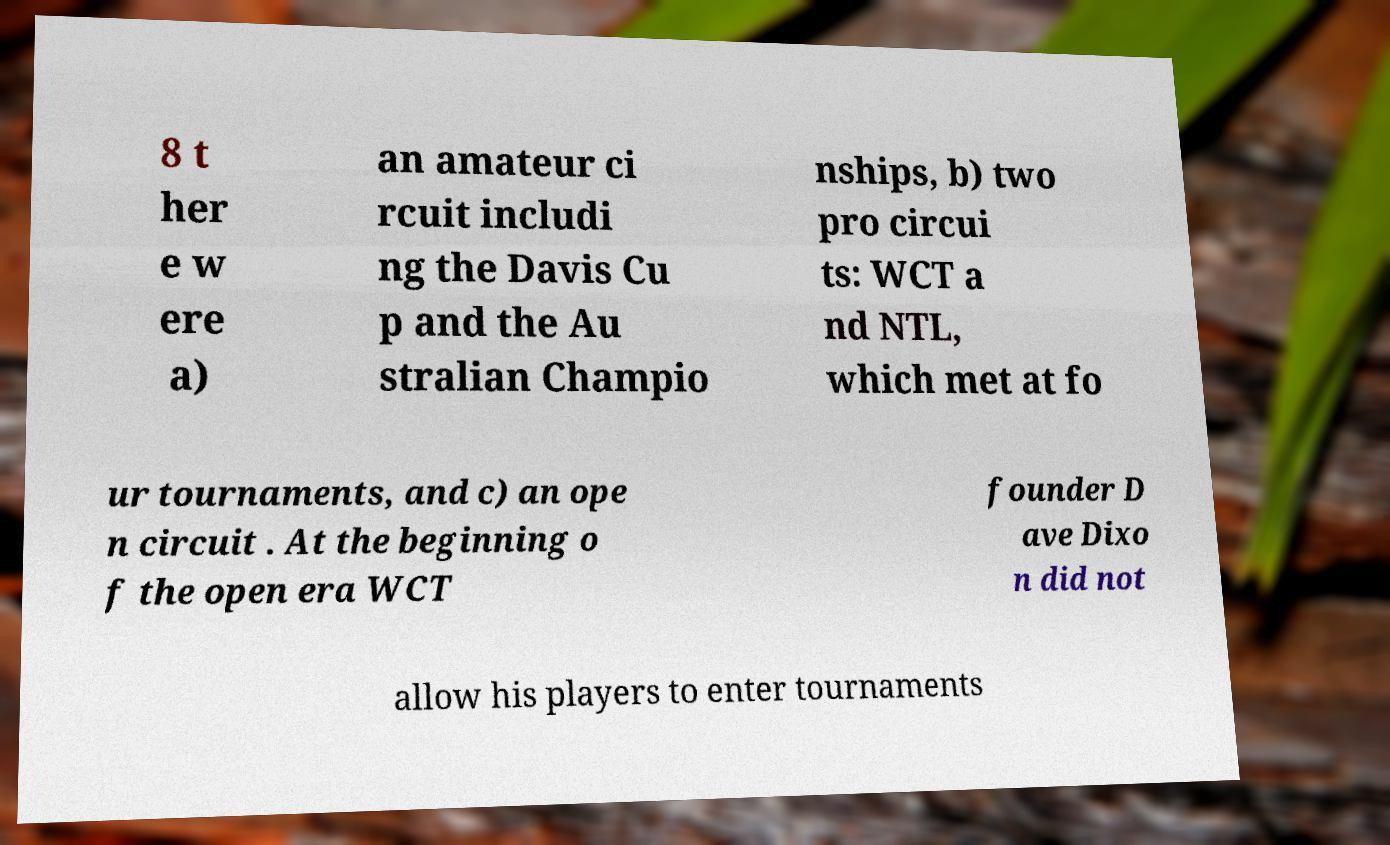What messages or text are displayed in this image? I need them in a readable, typed format. 8 t her e w ere a) an amateur ci rcuit includi ng the Davis Cu p and the Au stralian Champio nships, b) two pro circui ts: WCT a nd NTL, which met at fo ur tournaments, and c) an ope n circuit . At the beginning o f the open era WCT founder D ave Dixo n did not allow his players to enter tournaments 